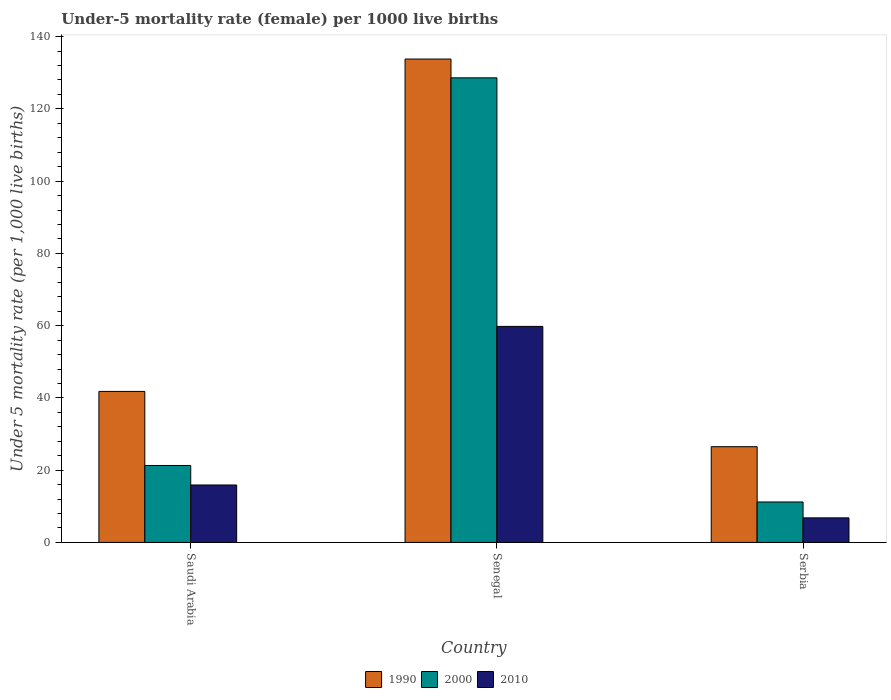How many different coloured bars are there?
Your response must be concise. 3. How many groups of bars are there?
Give a very brief answer. 3. Are the number of bars on each tick of the X-axis equal?
Provide a short and direct response. Yes. How many bars are there on the 2nd tick from the left?
Provide a short and direct response. 3. How many bars are there on the 2nd tick from the right?
Offer a very short reply. 3. What is the label of the 2nd group of bars from the left?
Offer a terse response. Senegal. Across all countries, what is the maximum under-five mortality rate in 1990?
Make the answer very short. 133.8. Across all countries, what is the minimum under-five mortality rate in 2010?
Your response must be concise. 6.8. In which country was the under-five mortality rate in 1990 maximum?
Provide a short and direct response. Senegal. In which country was the under-five mortality rate in 2000 minimum?
Your answer should be compact. Serbia. What is the total under-five mortality rate in 2010 in the graph?
Offer a very short reply. 82.5. What is the difference between the under-five mortality rate in 1990 in Saudi Arabia and that in Senegal?
Offer a terse response. -92. What is the difference between the under-five mortality rate in 2010 in Saudi Arabia and the under-five mortality rate in 2000 in Senegal?
Ensure brevity in your answer.  -112.7. What is the average under-five mortality rate in 2000 per country?
Offer a terse response. 53.7. What is the difference between the under-five mortality rate of/in 2010 and under-five mortality rate of/in 1990 in Saudi Arabia?
Offer a very short reply. -25.9. In how many countries, is the under-five mortality rate in 1990 greater than 136?
Offer a very short reply. 0. What is the ratio of the under-five mortality rate in 2000 in Saudi Arabia to that in Senegal?
Give a very brief answer. 0.17. Is the under-five mortality rate in 1990 in Saudi Arabia less than that in Senegal?
Provide a short and direct response. Yes. What is the difference between the highest and the second highest under-five mortality rate in 2000?
Provide a succinct answer. 117.4. What is the difference between the highest and the lowest under-five mortality rate in 1990?
Provide a succinct answer. 107.3. In how many countries, is the under-five mortality rate in 2010 greater than the average under-five mortality rate in 2010 taken over all countries?
Offer a terse response. 1. Is it the case that in every country, the sum of the under-five mortality rate in 1990 and under-five mortality rate in 2000 is greater than the under-five mortality rate in 2010?
Offer a very short reply. Yes. Are all the bars in the graph horizontal?
Your response must be concise. No. How many countries are there in the graph?
Your answer should be very brief. 3. Are the values on the major ticks of Y-axis written in scientific E-notation?
Ensure brevity in your answer.  No. How many legend labels are there?
Keep it short and to the point. 3. What is the title of the graph?
Your response must be concise. Under-5 mortality rate (female) per 1000 live births. Does "2010" appear as one of the legend labels in the graph?
Provide a short and direct response. Yes. What is the label or title of the X-axis?
Keep it short and to the point. Country. What is the label or title of the Y-axis?
Give a very brief answer. Under 5 mortality rate (per 1,0 live births). What is the Under 5 mortality rate (per 1,000 live births) of 1990 in Saudi Arabia?
Your response must be concise. 41.8. What is the Under 5 mortality rate (per 1,000 live births) in 2000 in Saudi Arabia?
Provide a short and direct response. 21.3. What is the Under 5 mortality rate (per 1,000 live births) of 2010 in Saudi Arabia?
Provide a short and direct response. 15.9. What is the Under 5 mortality rate (per 1,000 live births) in 1990 in Senegal?
Give a very brief answer. 133.8. What is the Under 5 mortality rate (per 1,000 live births) in 2000 in Senegal?
Give a very brief answer. 128.6. What is the Under 5 mortality rate (per 1,000 live births) in 2010 in Senegal?
Ensure brevity in your answer.  59.8. What is the Under 5 mortality rate (per 1,000 live births) in 1990 in Serbia?
Keep it short and to the point. 26.5. What is the Under 5 mortality rate (per 1,000 live births) in 2000 in Serbia?
Your answer should be very brief. 11.2. What is the Under 5 mortality rate (per 1,000 live births) of 2010 in Serbia?
Provide a succinct answer. 6.8. Across all countries, what is the maximum Under 5 mortality rate (per 1,000 live births) of 1990?
Offer a terse response. 133.8. Across all countries, what is the maximum Under 5 mortality rate (per 1,000 live births) in 2000?
Ensure brevity in your answer.  128.6. Across all countries, what is the maximum Under 5 mortality rate (per 1,000 live births) in 2010?
Your response must be concise. 59.8. Across all countries, what is the minimum Under 5 mortality rate (per 1,000 live births) in 1990?
Your answer should be very brief. 26.5. Across all countries, what is the minimum Under 5 mortality rate (per 1,000 live births) of 2010?
Your response must be concise. 6.8. What is the total Under 5 mortality rate (per 1,000 live births) in 1990 in the graph?
Give a very brief answer. 202.1. What is the total Under 5 mortality rate (per 1,000 live births) in 2000 in the graph?
Ensure brevity in your answer.  161.1. What is the total Under 5 mortality rate (per 1,000 live births) in 2010 in the graph?
Your answer should be very brief. 82.5. What is the difference between the Under 5 mortality rate (per 1,000 live births) of 1990 in Saudi Arabia and that in Senegal?
Make the answer very short. -92. What is the difference between the Under 5 mortality rate (per 1,000 live births) of 2000 in Saudi Arabia and that in Senegal?
Keep it short and to the point. -107.3. What is the difference between the Under 5 mortality rate (per 1,000 live births) of 2010 in Saudi Arabia and that in Senegal?
Your answer should be compact. -43.9. What is the difference between the Under 5 mortality rate (per 1,000 live births) in 1990 in Saudi Arabia and that in Serbia?
Your answer should be very brief. 15.3. What is the difference between the Under 5 mortality rate (per 1,000 live births) in 2000 in Saudi Arabia and that in Serbia?
Provide a succinct answer. 10.1. What is the difference between the Under 5 mortality rate (per 1,000 live births) of 2010 in Saudi Arabia and that in Serbia?
Your answer should be compact. 9.1. What is the difference between the Under 5 mortality rate (per 1,000 live births) of 1990 in Senegal and that in Serbia?
Make the answer very short. 107.3. What is the difference between the Under 5 mortality rate (per 1,000 live births) of 2000 in Senegal and that in Serbia?
Offer a very short reply. 117.4. What is the difference between the Under 5 mortality rate (per 1,000 live births) in 2010 in Senegal and that in Serbia?
Make the answer very short. 53. What is the difference between the Under 5 mortality rate (per 1,000 live births) of 1990 in Saudi Arabia and the Under 5 mortality rate (per 1,000 live births) of 2000 in Senegal?
Offer a very short reply. -86.8. What is the difference between the Under 5 mortality rate (per 1,000 live births) in 2000 in Saudi Arabia and the Under 5 mortality rate (per 1,000 live births) in 2010 in Senegal?
Ensure brevity in your answer.  -38.5. What is the difference between the Under 5 mortality rate (per 1,000 live births) in 1990 in Saudi Arabia and the Under 5 mortality rate (per 1,000 live births) in 2000 in Serbia?
Provide a succinct answer. 30.6. What is the difference between the Under 5 mortality rate (per 1,000 live births) in 2000 in Saudi Arabia and the Under 5 mortality rate (per 1,000 live births) in 2010 in Serbia?
Offer a very short reply. 14.5. What is the difference between the Under 5 mortality rate (per 1,000 live births) of 1990 in Senegal and the Under 5 mortality rate (per 1,000 live births) of 2000 in Serbia?
Provide a short and direct response. 122.6. What is the difference between the Under 5 mortality rate (per 1,000 live births) in 1990 in Senegal and the Under 5 mortality rate (per 1,000 live births) in 2010 in Serbia?
Your answer should be compact. 127. What is the difference between the Under 5 mortality rate (per 1,000 live births) in 2000 in Senegal and the Under 5 mortality rate (per 1,000 live births) in 2010 in Serbia?
Give a very brief answer. 121.8. What is the average Under 5 mortality rate (per 1,000 live births) in 1990 per country?
Your response must be concise. 67.37. What is the average Under 5 mortality rate (per 1,000 live births) of 2000 per country?
Ensure brevity in your answer.  53.7. What is the average Under 5 mortality rate (per 1,000 live births) of 2010 per country?
Provide a short and direct response. 27.5. What is the difference between the Under 5 mortality rate (per 1,000 live births) in 1990 and Under 5 mortality rate (per 1,000 live births) in 2000 in Saudi Arabia?
Ensure brevity in your answer.  20.5. What is the difference between the Under 5 mortality rate (per 1,000 live births) of 1990 and Under 5 mortality rate (per 1,000 live births) of 2010 in Saudi Arabia?
Keep it short and to the point. 25.9. What is the difference between the Under 5 mortality rate (per 1,000 live births) in 1990 and Under 5 mortality rate (per 1,000 live births) in 2000 in Senegal?
Provide a succinct answer. 5.2. What is the difference between the Under 5 mortality rate (per 1,000 live births) in 1990 and Under 5 mortality rate (per 1,000 live births) in 2010 in Senegal?
Your response must be concise. 74. What is the difference between the Under 5 mortality rate (per 1,000 live births) in 2000 and Under 5 mortality rate (per 1,000 live births) in 2010 in Senegal?
Provide a succinct answer. 68.8. What is the difference between the Under 5 mortality rate (per 1,000 live births) of 1990 and Under 5 mortality rate (per 1,000 live births) of 2000 in Serbia?
Make the answer very short. 15.3. What is the difference between the Under 5 mortality rate (per 1,000 live births) of 2000 and Under 5 mortality rate (per 1,000 live births) of 2010 in Serbia?
Your answer should be compact. 4.4. What is the ratio of the Under 5 mortality rate (per 1,000 live births) of 1990 in Saudi Arabia to that in Senegal?
Make the answer very short. 0.31. What is the ratio of the Under 5 mortality rate (per 1,000 live births) in 2000 in Saudi Arabia to that in Senegal?
Offer a terse response. 0.17. What is the ratio of the Under 5 mortality rate (per 1,000 live births) of 2010 in Saudi Arabia to that in Senegal?
Offer a terse response. 0.27. What is the ratio of the Under 5 mortality rate (per 1,000 live births) of 1990 in Saudi Arabia to that in Serbia?
Provide a short and direct response. 1.58. What is the ratio of the Under 5 mortality rate (per 1,000 live births) in 2000 in Saudi Arabia to that in Serbia?
Offer a terse response. 1.9. What is the ratio of the Under 5 mortality rate (per 1,000 live births) of 2010 in Saudi Arabia to that in Serbia?
Offer a very short reply. 2.34. What is the ratio of the Under 5 mortality rate (per 1,000 live births) in 1990 in Senegal to that in Serbia?
Your answer should be very brief. 5.05. What is the ratio of the Under 5 mortality rate (per 1,000 live births) of 2000 in Senegal to that in Serbia?
Give a very brief answer. 11.48. What is the ratio of the Under 5 mortality rate (per 1,000 live births) in 2010 in Senegal to that in Serbia?
Keep it short and to the point. 8.79. What is the difference between the highest and the second highest Under 5 mortality rate (per 1,000 live births) in 1990?
Provide a short and direct response. 92. What is the difference between the highest and the second highest Under 5 mortality rate (per 1,000 live births) of 2000?
Provide a short and direct response. 107.3. What is the difference between the highest and the second highest Under 5 mortality rate (per 1,000 live births) of 2010?
Keep it short and to the point. 43.9. What is the difference between the highest and the lowest Under 5 mortality rate (per 1,000 live births) of 1990?
Give a very brief answer. 107.3. What is the difference between the highest and the lowest Under 5 mortality rate (per 1,000 live births) of 2000?
Offer a very short reply. 117.4. What is the difference between the highest and the lowest Under 5 mortality rate (per 1,000 live births) of 2010?
Provide a short and direct response. 53. 